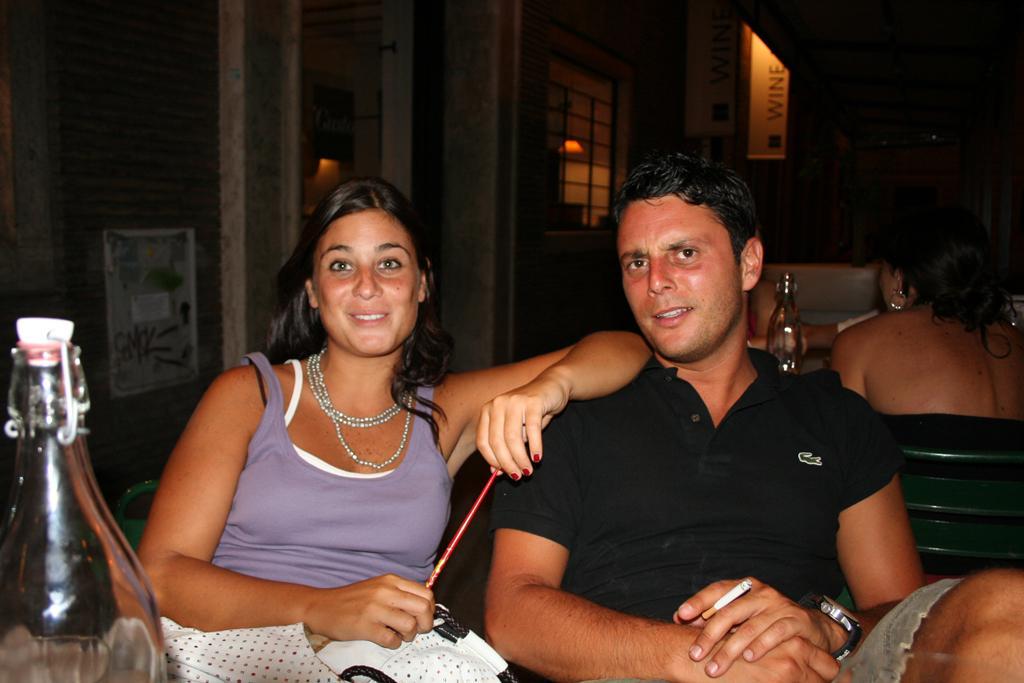Can you describe this image briefly? In the image we can see there are people who are sitting on chair and at the back there are other people who are sitting. 